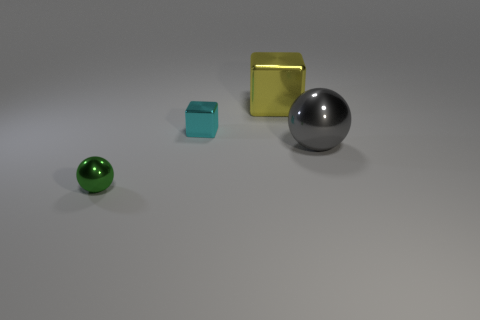Add 1 large balls. How many objects exist? 5 Subtract all cyan blocks. How many blocks are left? 1 Add 1 tiny purple cylinders. How many tiny purple cylinders exist? 1 Subtract 1 yellow cubes. How many objects are left? 3 Subtract all purple balls. Subtract all green cylinders. How many balls are left? 2 Subtract all yellow metallic blocks. Subtract all green objects. How many objects are left? 2 Add 4 gray shiny things. How many gray shiny things are left? 5 